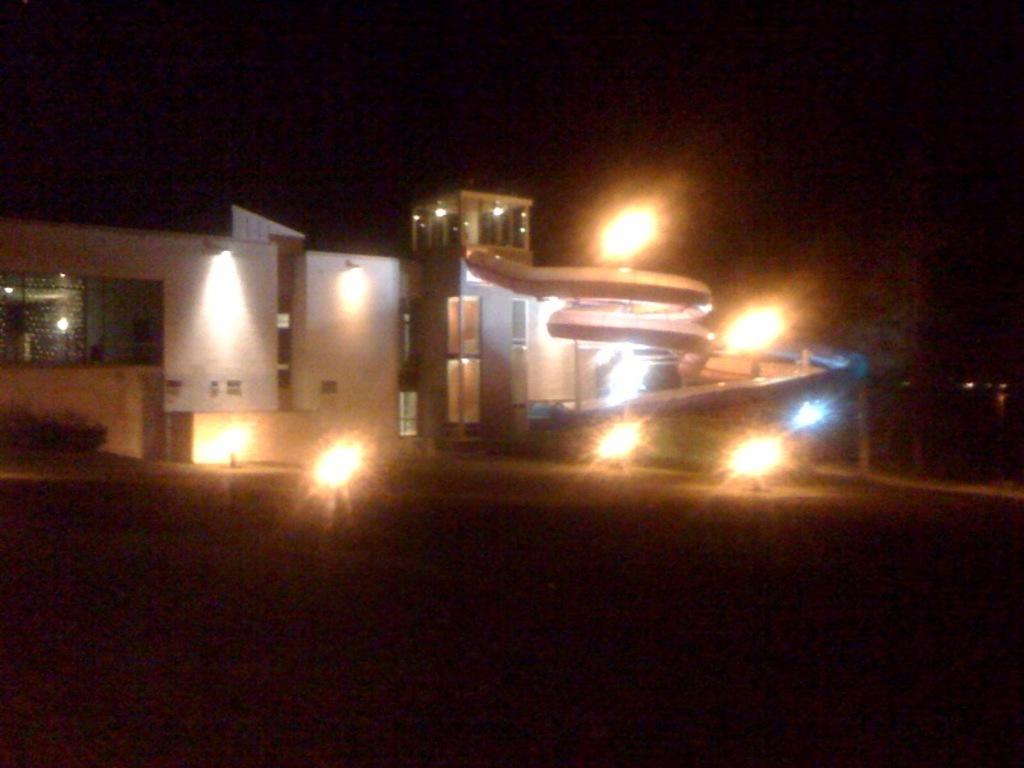What type of structure is visible in the image? There is a building in the image. What feature can be seen on the building? The building has glass windows. Are there any other notable features of the building? The building has lights. What else can be seen in the image besides the building? There are other objects in the image. How would you describe the lighting in the image? The top and bottom of the image have a dark view. Can you see a police officer wearing a mitten in the image? There is no police officer or mitten present in the image. Is there a bed visible in the image? There is no bed visible in the image. 